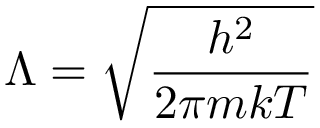<formula> <loc_0><loc_0><loc_500><loc_500>\Lambda = { \sqrt { \frac { h ^ { 2 } } { 2 \pi m k T } } }</formula> 